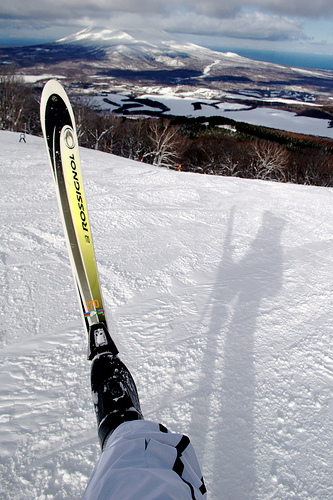<image>
Can you confirm if the ski is on the boot? Yes. Looking at the image, I can see the ski is positioned on top of the boot, with the boot providing support. 